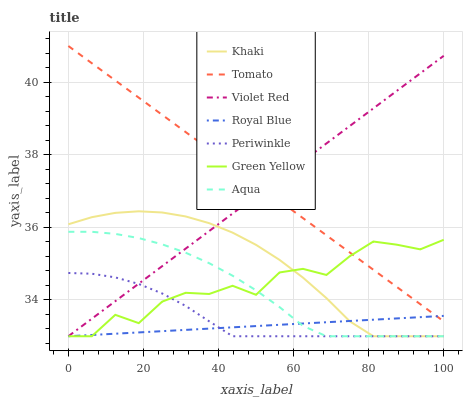Does Royal Blue have the minimum area under the curve?
Answer yes or no. Yes. Does Tomato have the maximum area under the curve?
Answer yes or no. Yes. Does Violet Red have the minimum area under the curve?
Answer yes or no. No. Does Violet Red have the maximum area under the curve?
Answer yes or no. No. Is Tomato the smoothest?
Answer yes or no. Yes. Is Green Yellow the roughest?
Answer yes or no. Yes. Is Violet Red the smoothest?
Answer yes or no. No. Is Violet Red the roughest?
Answer yes or no. No. Does Violet Red have the lowest value?
Answer yes or no. Yes. Does Tomato have the highest value?
Answer yes or no. Yes. Does Violet Red have the highest value?
Answer yes or no. No. Is Aqua less than Tomato?
Answer yes or no. Yes. Is Tomato greater than Periwinkle?
Answer yes or no. Yes. Does Aqua intersect Violet Red?
Answer yes or no. Yes. Is Aqua less than Violet Red?
Answer yes or no. No. Is Aqua greater than Violet Red?
Answer yes or no. No. Does Aqua intersect Tomato?
Answer yes or no. No. 